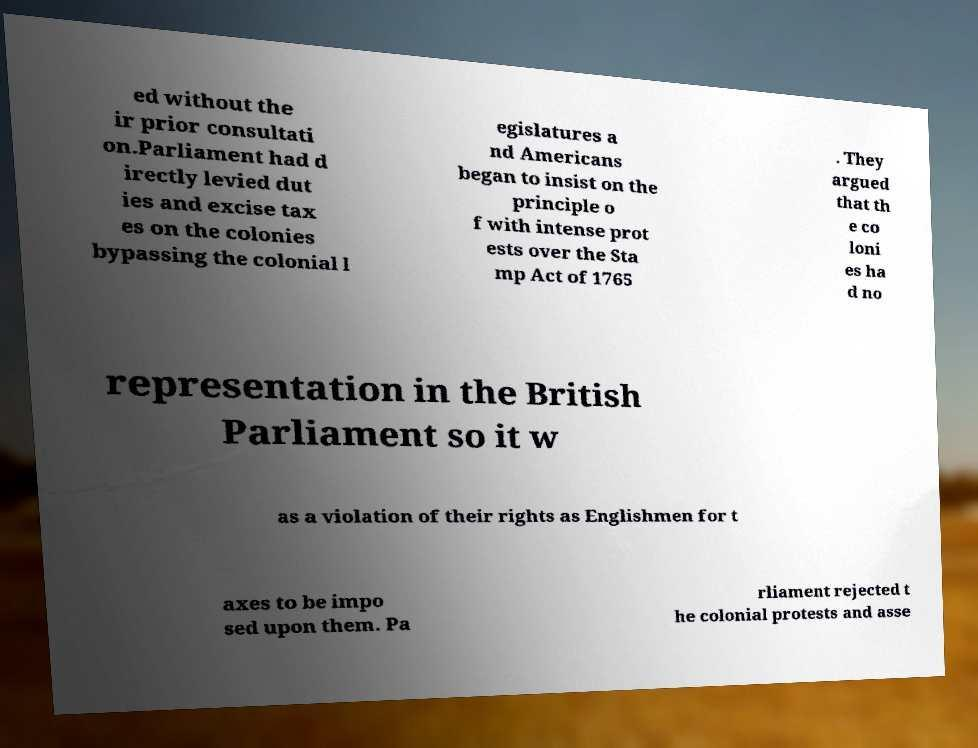I need the written content from this picture converted into text. Can you do that? ed without the ir prior consultati on.Parliament had d irectly levied dut ies and excise tax es on the colonies bypassing the colonial l egislatures a nd Americans began to insist on the principle o f with intense prot ests over the Sta mp Act of 1765 . They argued that th e co loni es ha d no representation in the British Parliament so it w as a violation of their rights as Englishmen for t axes to be impo sed upon them. Pa rliament rejected t he colonial protests and asse 